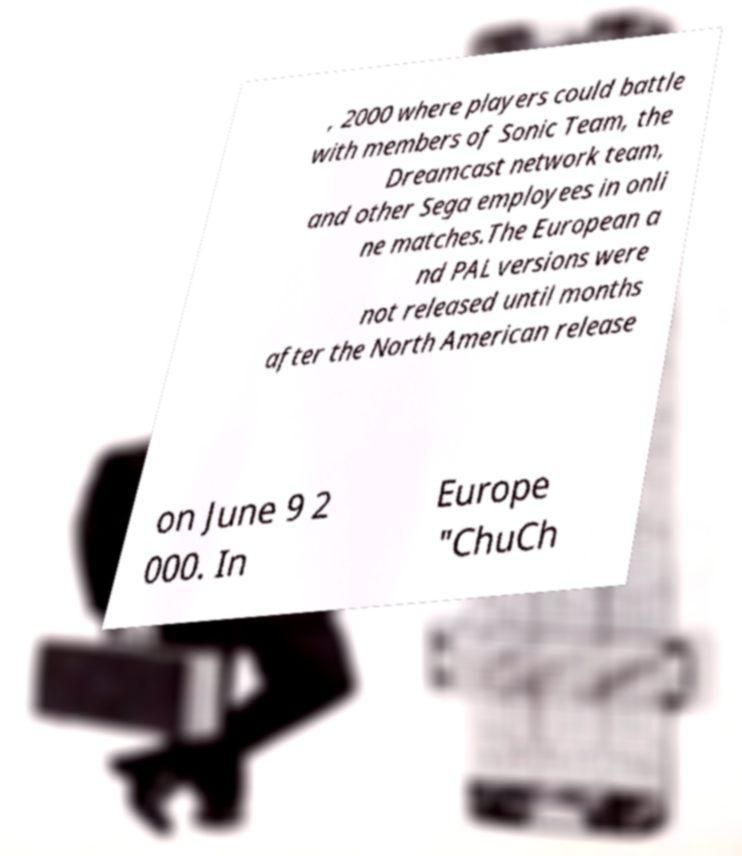Can you accurately transcribe the text from the provided image for me? , 2000 where players could battle with members of Sonic Team, the Dreamcast network team, and other Sega employees in onli ne matches.The European a nd PAL versions were not released until months after the North American release on June 9 2 000. In Europe "ChuCh 